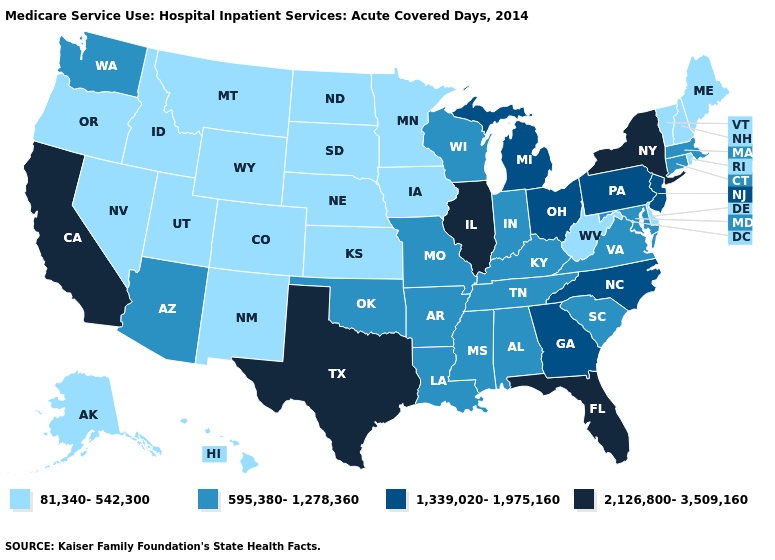Does the first symbol in the legend represent the smallest category?
Short answer required. Yes. Name the states that have a value in the range 595,380-1,278,360?
Write a very short answer. Alabama, Arizona, Arkansas, Connecticut, Indiana, Kentucky, Louisiana, Maryland, Massachusetts, Mississippi, Missouri, Oklahoma, South Carolina, Tennessee, Virginia, Washington, Wisconsin. Name the states that have a value in the range 1,339,020-1,975,160?
Answer briefly. Georgia, Michigan, New Jersey, North Carolina, Ohio, Pennsylvania. What is the value of New York?
Be succinct. 2,126,800-3,509,160. Does the first symbol in the legend represent the smallest category?
Write a very short answer. Yes. What is the value of Texas?
Keep it brief. 2,126,800-3,509,160. Name the states that have a value in the range 81,340-542,300?
Give a very brief answer. Alaska, Colorado, Delaware, Hawaii, Idaho, Iowa, Kansas, Maine, Minnesota, Montana, Nebraska, Nevada, New Hampshire, New Mexico, North Dakota, Oregon, Rhode Island, South Dakota, Utah, Vermont, West Virginia, Wyoming. Does the map have missing data?
Concise answer only. No. What is the lowest value in states that border Mississippi?
Write a very short answer. 595,380-1,278,360. Name the states that have a value in the range 1,339,020-1,975,160?
Short answer required. Georgia, Michigan, New Jersey, North Carolina, Ohio, Pennsylvania. Name the states that have a value in the range 2,126,800-3,509,160?
Write a very short answer. California, Florida, Illinois, New York, Texas. What is the value of Arizona?
Concise answer only. 595,380-1,278,360. What is the lowest value in the South?
Be succinct. 81,340-542,300. Name the states that have a value in the range 1,339,020-1,975,160?
Write a very short answer. Georgia, Michigan, New Jersey, North Carolina, Ohio, Pennsylvania. 